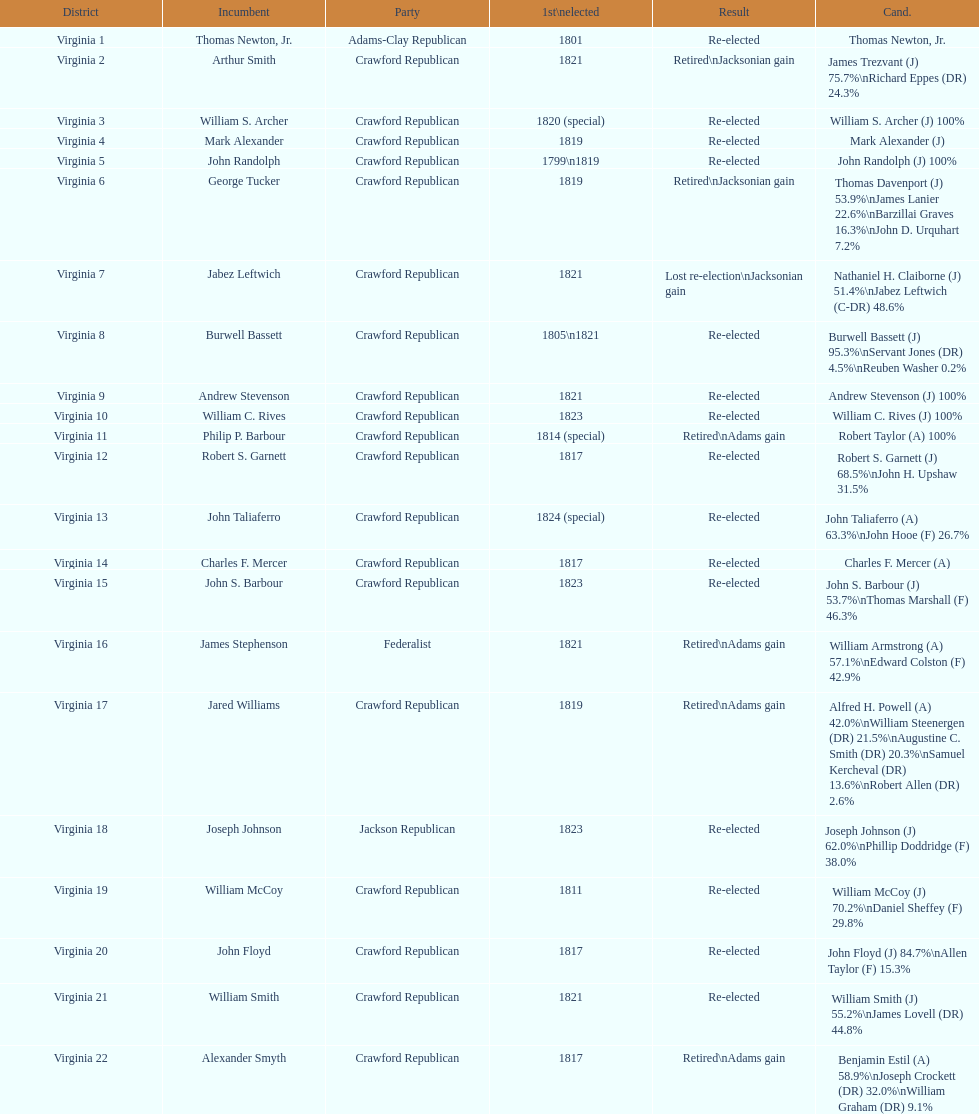Tell me the number of people first elected in 1817. 4. 